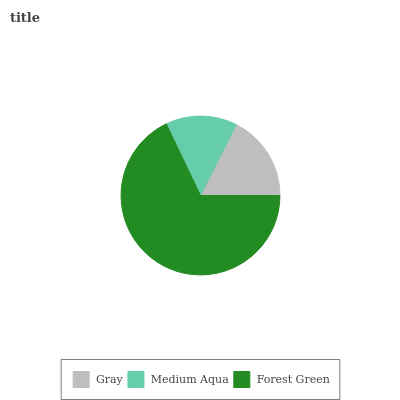Is Medium Aqua the minimum?
Answer yes or no. Yes. Is Forest Green the maximum?
Answer yes or no. Yes. Is Forest Green the minimum?
Answer yes or no. No. Is Medium Aqua the maximum?
Answer yes or no. No. Is Forest Green greater than Medium Aqua?
Answer yes or no. Yes. Is Medium Aqua less than Forest Green?
Answer yes or no. Yes. Is Medium Aqua greater than Forest Green?
Answer yes or no. No. Is Forest Green less than Medium Aqua?
Answer yes or no. No. Is Gray the high median?
Answer yes or no. Yes. Is Gray the low median?
Answer yes or no. Yes. Is Forest Green the high median?
Answer yes or no. No. Is Forest Green the low median?
Answer yes or no. No. 